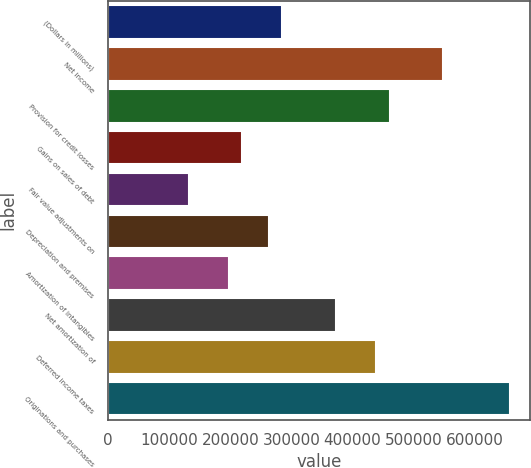Convert chart to OTSL. <chart><loc_0><loc_0><loc_500><loc_500><bar_chart><fcel>(Dollars in millions)<fcel>Net income<fcel>Provision for credit losses<fcel>Gains on sales of debt<fcel>Fair value adjustments on<fcel>Depreciation and premises<fcel>Amortization of intangibles<fcel>Net amortization of<fcel>Deferred income taxes<fcel>Originations and purchases<nl><fcel>285231<fcel>548506<fcel>460748<fcel>219412<fcel>131654<fcel>263291<fcel>197472<fcel>372989<fcel>438808<fcel>658204<nl></chart> 